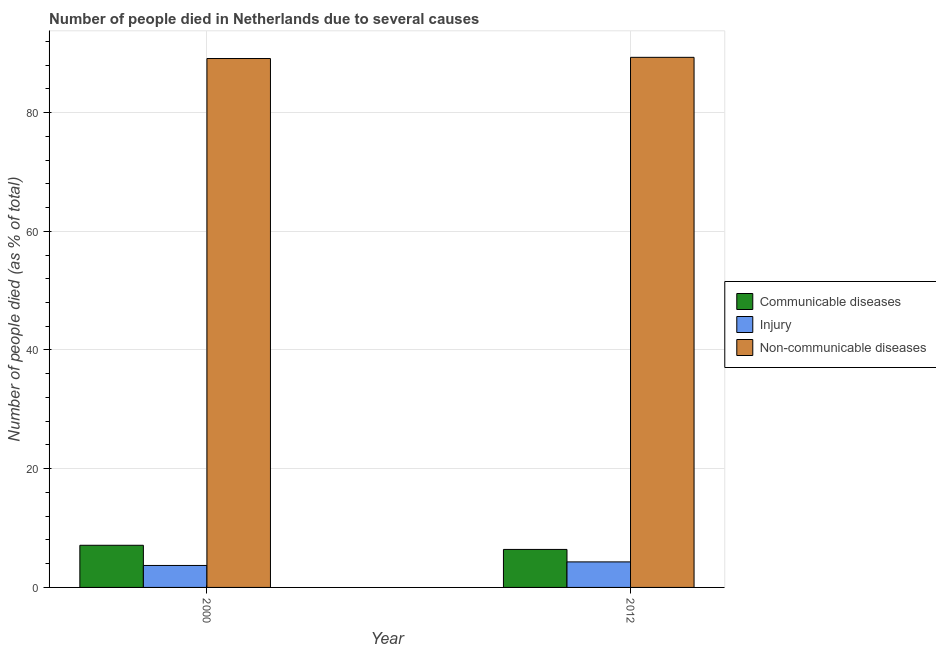How many different coloured bars are there?
Your answer should be very brief. 3. Are the number of bars on each tick of the X-axis equal?
Ensure brevity in your answer.  Yes. How many bars are there on the 2nd tick from the right?
Offer a very short reply. 3. What is the number of people who died of injury in 2012?
Provide a succinct answer. 4.3. Across all years, what is the minimum number of people who died of communicable diseases?
Your response must be concise. 6.4. In which year was the number of people who dies of non-communicable diseases maximum?
Your answer should be very brief. 2012. What is the total number of people who dies of non-communicable diseases in the graph?
Provide a short and direct response. 178.4. What is the difference between the number of people who died of communicable diseases in 2000 and that in 2012?
Provide a short and direct response. 0.7. What is the difference between the number of people who died of communicable diseases in 2000 and the number of people who dies of non-communicable diseases in 2012?
Ensure brevity in your answer.  0.7. What is the ratio of the number of people who died of communicable diseases in 2000 to that in 2012?
Make the answer very short. 1.11. Is the number of people who dies of non-communicable diseases in 2000 less than that in 2012?
Offer a terse response. Yes. In how many years, is the number of people who died of communicable diseases greater than the average number of people who died of communicable diseases taken over all years?
Make the answer very short. 1. What does the 1st bar from the left in 2012 represents?
Ensure brevity in your answer.  Communicable diseases. What does the 1st bar from the right in 2000 represents?
Keep it short and to the point. Non-communicable diseases. How many bars are there?
Offer a very short reply. 6. Are the values on the major ticks of Y-axis written in scientific E-notation?
Your answer should be very brief. No. Does the graph contain any zero values?
Offer a terse response. No. How many legend labels are there?
Provide a succinct answer. 3. What is the title of the graph?
Keep it short and to the point. Number of people died in Netherlands due to several causes. Does "Male employers" appear as one of the legend labels in the graph?
Give a very brief answer. No. What is the label or title of the Y-axis?
Make the answer very short. Number of people died (as % of total). What is the Number of people died (as % of total) of Injury in 2000?
Offer a terse response. 3.7. What is the Number of people died (as % of total) of Non-communicable diseases in 2000?
Provide a succinct answer. 89.1. What is the Number of people died (as % of total) in Communicable diseases in 2012?
Keep it short and to the point. 6.4. What is the Number of people died (as % of total) in Injury in 2012?
Offer a very short reply. 4.3. What is the Number of people died (as % of total) in Non-communicable diseases in 2012?
Your response must be concise. 89.3. Across all years, what is the maximum Number of people died (as % of total) in Communicable diseases?
Your answer should be compact. 7.1. Across all years, what is the maximum Number of people died (as % of total) of Injury?
Provide a short and direct response. 4.3. Across all years, what is the maximum Number of people died (as % of total) of Non-communicable diseases?
Provide a succinct answer. 89.3. Across all years, what is the minimum Number of people died (as % of total) in Non-communicable diseases?
Provide a succinct answer. 89.1. What is the total Number of people died (as % of total) of Injury in the graph?
Make the answer very short. 8. What is the total Number of people died (as % of total) in Non-communicable diseases in the graph?
Offer a very short reply. 178.4. What is the difference between the Number of people died (as % of total) of Injury in 2000 and that in 2012?
Ensure brevity in your answer.  -0.6. What is the difference between the Number of people died (as % of total) of Communicable diseases in 2000 and the Number of people died (as % of total) of Injury in 2012?
Offer a very short reply. 2.8. What is the difference between the Number of people died (as % of total) in Communicable diseases in 2000 and the Number of people died (as % of total) in Non-communicable diseases in 2012?
Your answer should be compact. -82.2. What is the difference between the Number of people died (as % of total) of Injury in 2000 and the Number of people died (as % of total) of Non-communicable diseases in 2012?
Your answer should be compact. -85.6. What is the average Number of people died (as % of total) of Communicable diseases per year?
Offer a terse response. 6.75. What is the average Number of people died (as % of total) of Injury per year?
Offer a very short reply. 4. What is the average Number of people died (as % of total) in Non-communicable diseases per year?
Ensure brevity in your answer.  89.2. In the year 2000, what is the difference between the Number of people died (as % of total) of Communicable diseases and Number of people died (as % of total) of Non-communicable diseases?
Give a very brief answer. -82. In the year 2000, what is the difference between the Number of people died (as % of total) of Injury and Number of people died (as % of total) of Non-communicable diseases?
Offer a terse response. -85.4. In the year 2012, what is the difference between the Number of people died (as % of total) in Communicable diseases and Number of people died (as % of total) in Non-communicable diseases?
Keep it short and to the point. -82.9. In the year 2012, what is the difference between the Number of people died (as % of total) of Injury and Number of people died (as % of total) of Non-communicable diseases?
Offer a very short reply. -85. What is the ratio of the Number of people died (as % of total) in Communicable diseases in 2000 to that in 2012?
Offer a terse response. 1.11. What is the ratio of the Number of people died (as % of total) in Injury in 2000 to that in 2012?
Your response must be concise. 0.86. What is the ratio of the Number of people died (as % of total) in Non-communicable diseases in 2000 to that in 2012?
Your response must be concise. 1. What is the difference between the highest and the second highest Number of people died (as % of total) in Communicable diseases?
Your answer should be compact. 0.7. What is the difference between the highest and the lowest Number of people died (as % of total) in Non-communicable diseases?
Give a very brief answer. 0.2. 